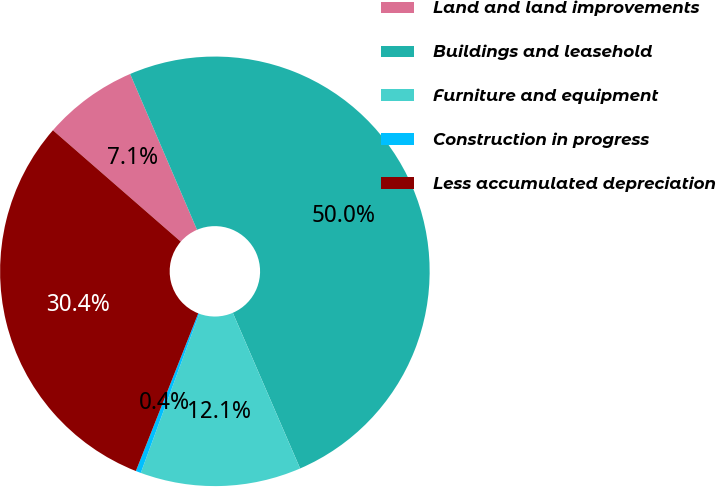Convert chart. <chart><loc_0><loc_0><loc_500><loc_500><pie_chart><fcel>Land and land improvements<fcel>Buildings and leasehold<fcel>Furniture and equipment<fcel>Construction in progress<fcel>Less accumulated depreciation<nl><fcel>7.14%<fcel>49.96%<fcel>12.1%<fcel>0.39%<fcel>30.41%<nl></chart> 